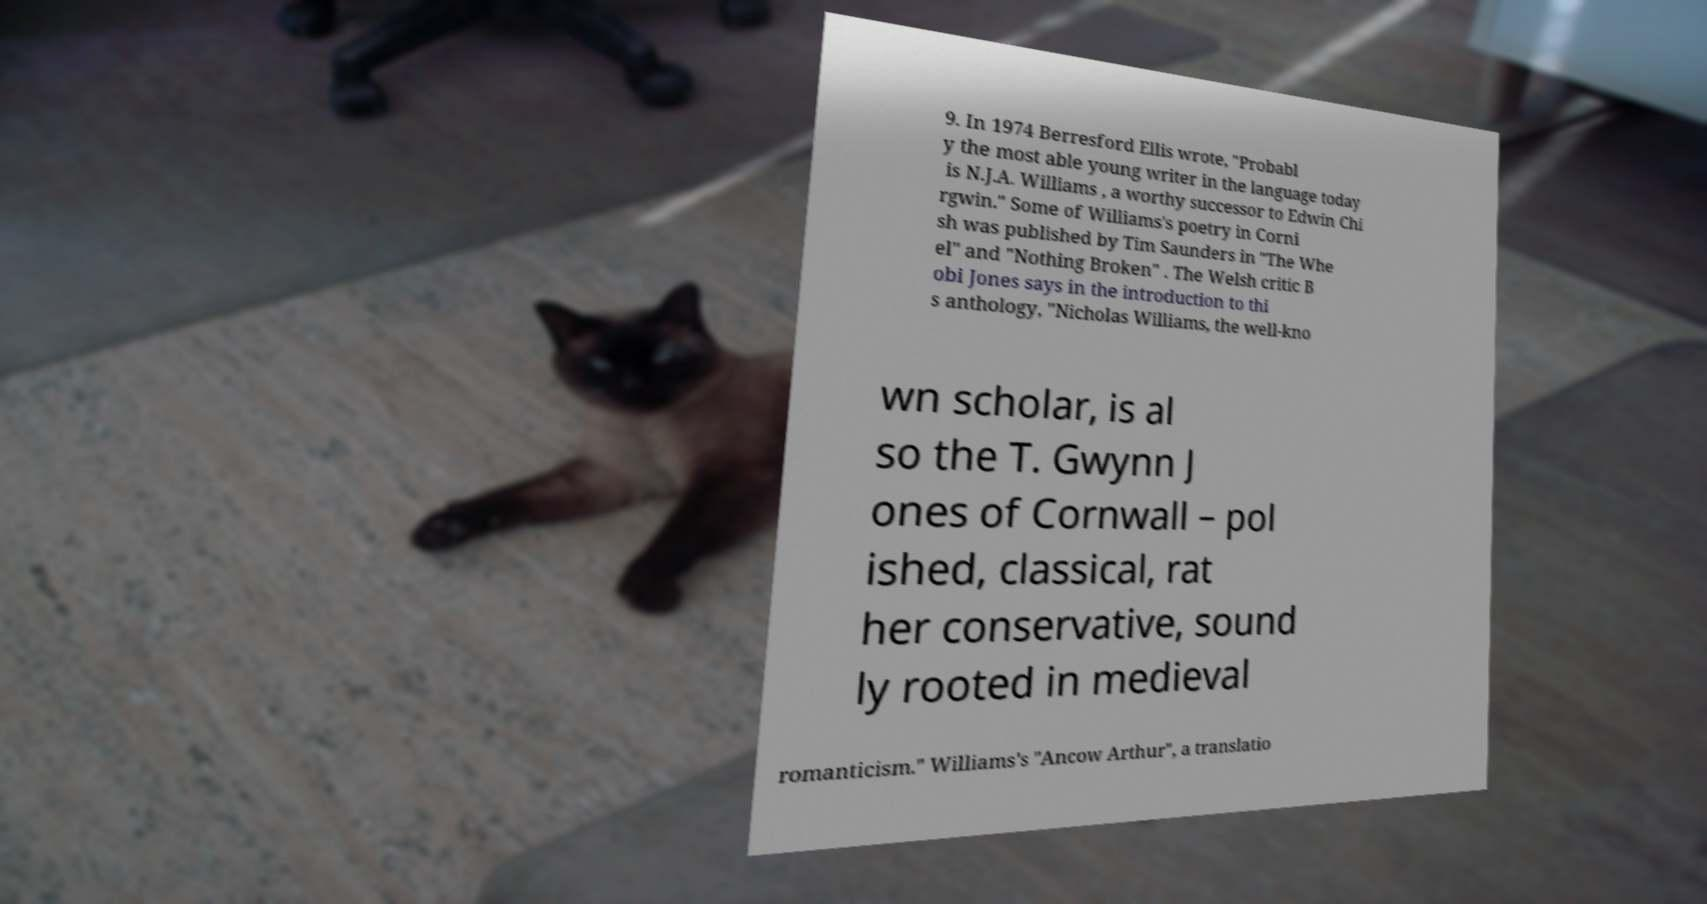What messages or text are displayed in this image? I need them in a readable, typed format. 9. In 1974 Berresford Ellis wrote, "Probabl y the most able young writer in the language today is N.J.A. Williams , a worthy successor to Edwin Chi rgwin." Some of Williams's poetry in Corni sh was published by Tim Saunders in "The Whe el" and "Nothing Broken" . The Welsh critic B obi Jones says in the introduction to thi s anthology, "Nicholas Williams, the well-kno wn scholar, is al so the T. Gwynn J ones of Cornwall – pol ished, classical, rat her conservative, sound ly rooted in medieval romanticism." Williams's "Ancow Arthur", a translatio 